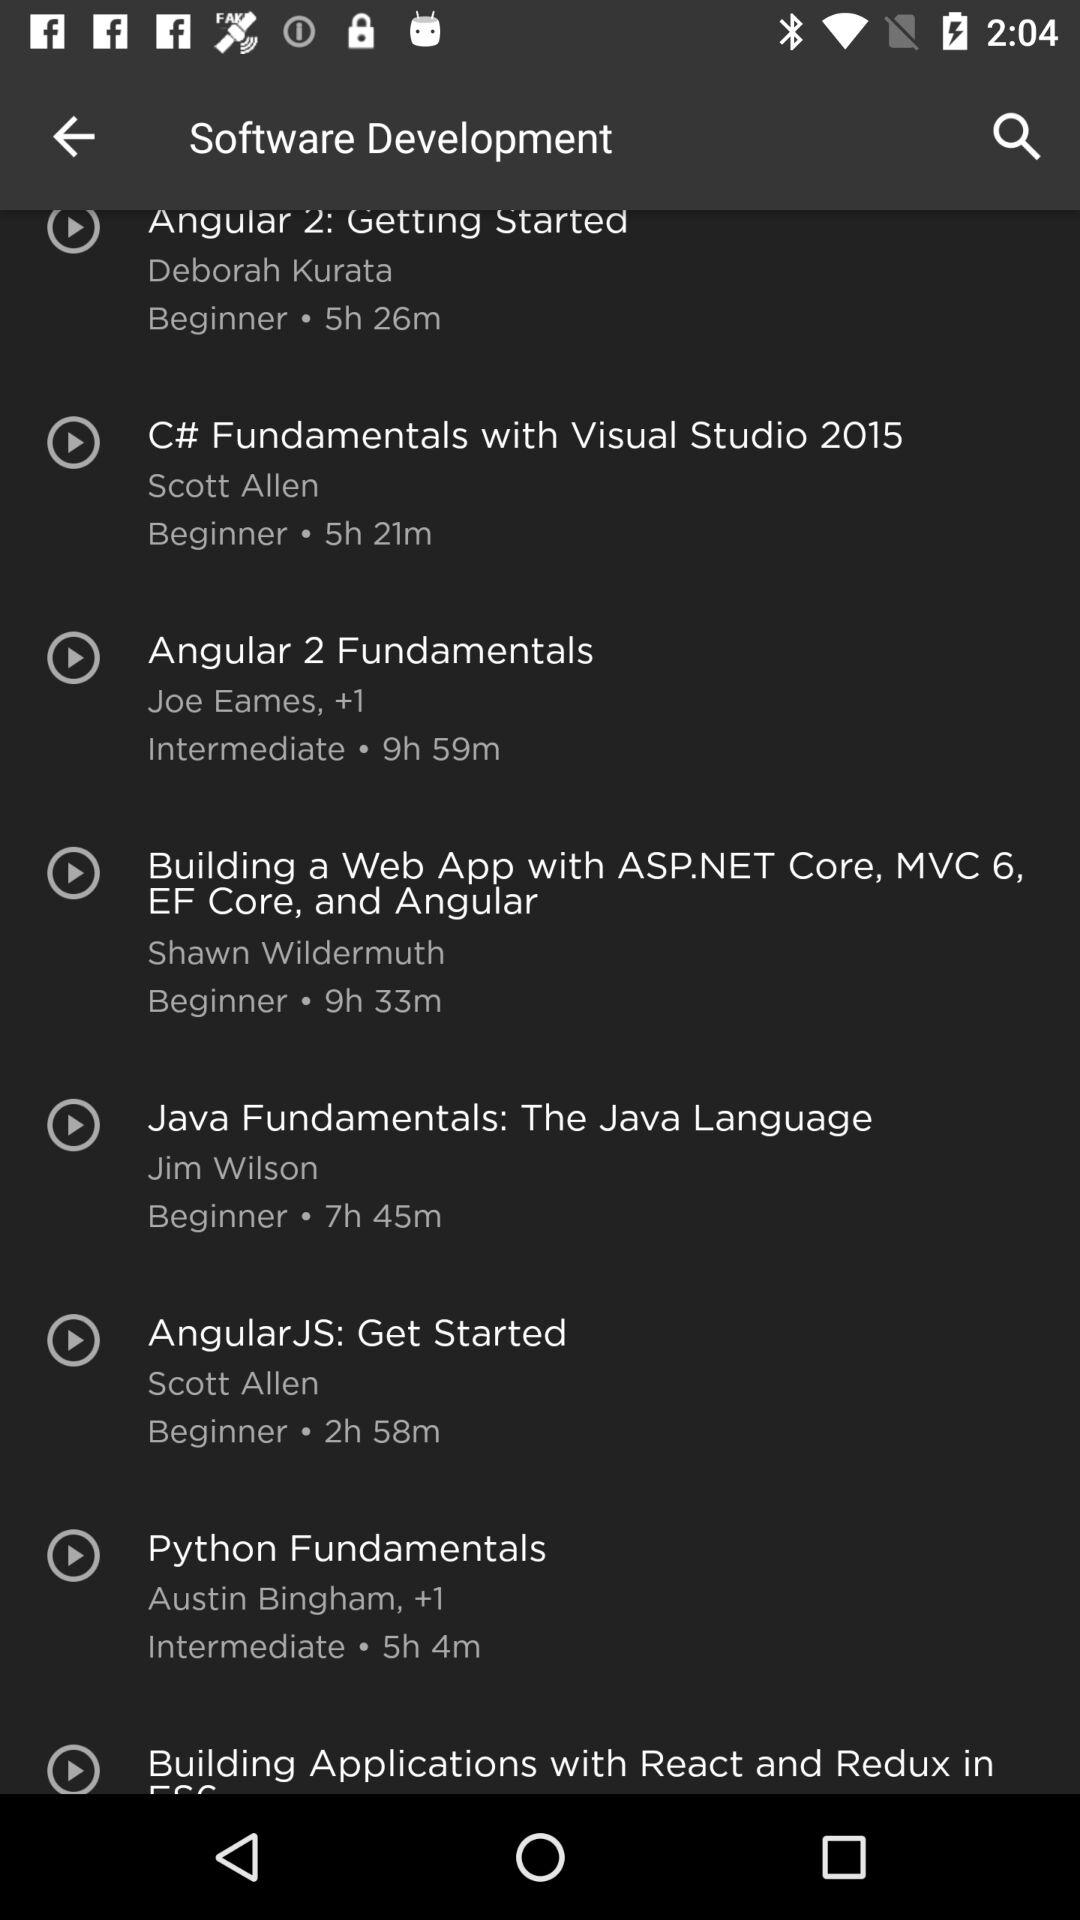Which fundamental course has a duration of 2 hours 58 minutes? The course that has a duration of 2 hours 58 minutes is "AngularJS: Get Started". 